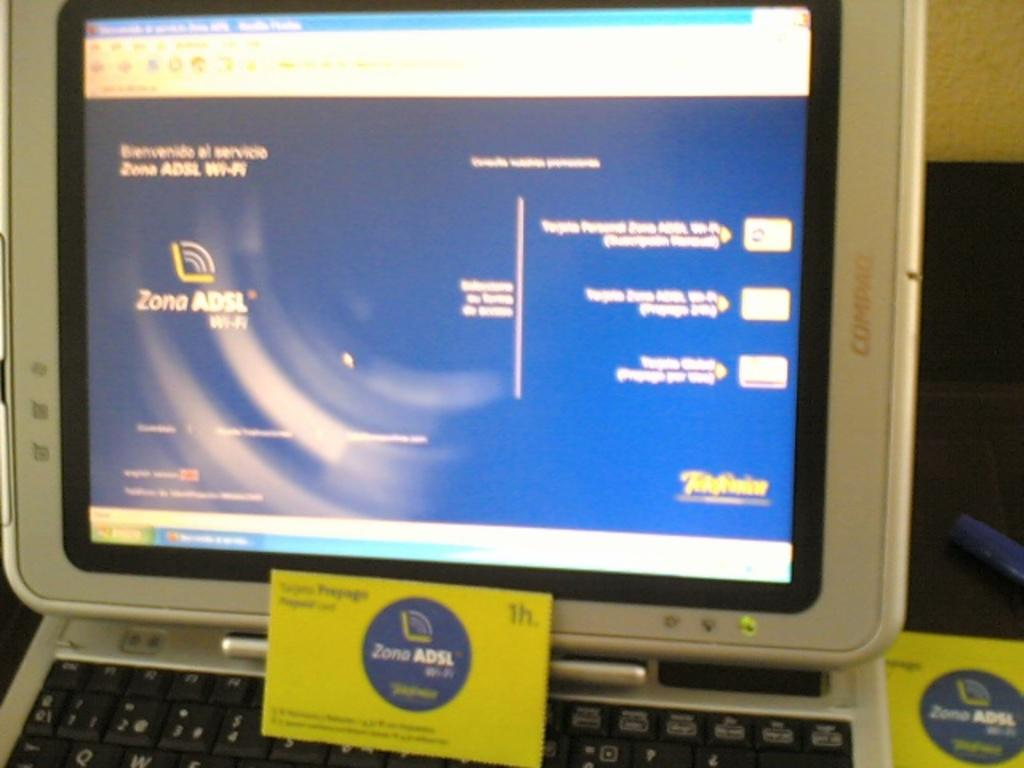<image>
Write a terse but informative summary of the picture. Lime green business card for Zone ADSL on top of a silver laptop. 